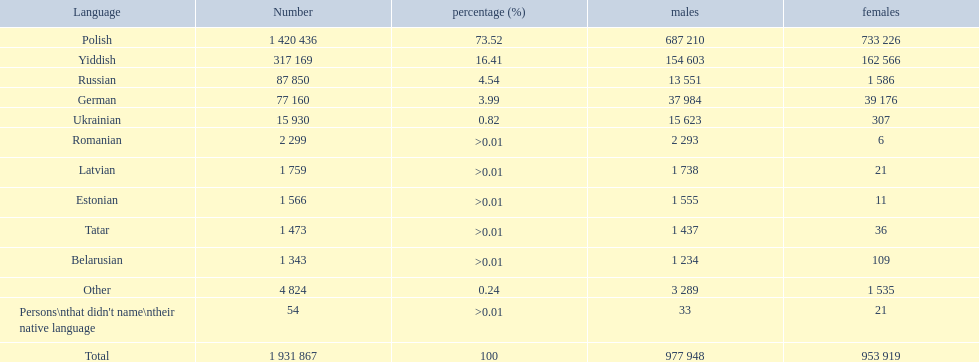Which indigenous languages spoken in the warsaw governorate have a higher male population than female? Russian, Ukrainian, Romanian, Latvian, Estonian, Tatar, Belarusian. Among those, which have fewer than 500 males recorded? Romanian, Latvian, Estonian, Tatar, Belarusian. Out of the remaining languages, which have fewer than 20 females? Romanian, Estonian. Among these, which has the largest total count? Romanian. 